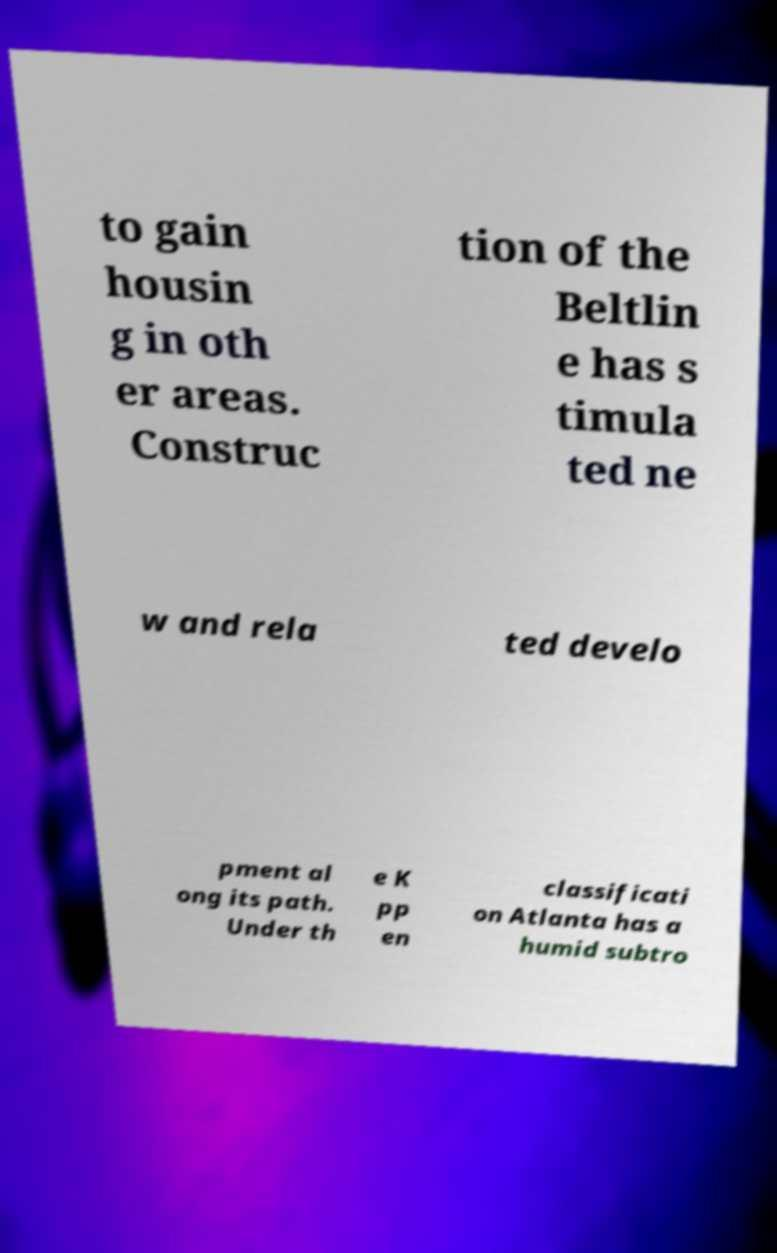There's text embedded in this image that I need extracted. Can you transcribe it verbatim? to gain housin g in oth er areas. Construc tion of the Beltlin e has s timula ted ne w and rela ted develo pment al ong its path. Under th e K pp en classificati on Atlanta has a humid subtro 